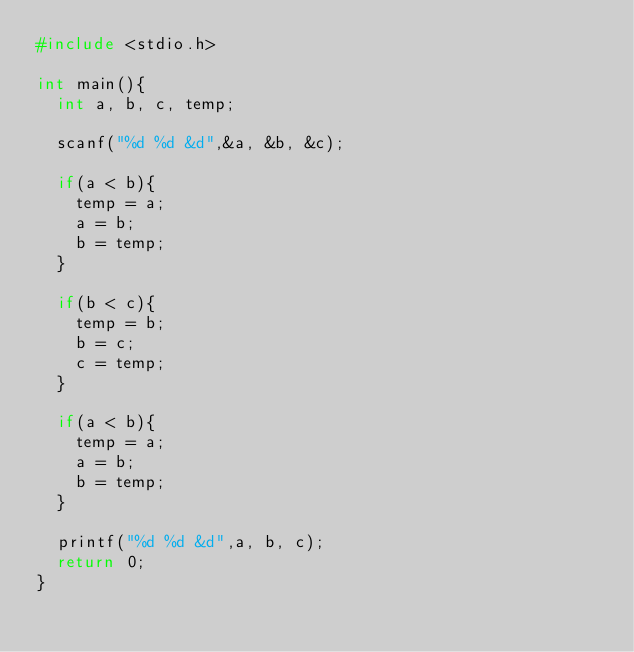<code> <loc_0><loc_0><loc_500><loc_500><_C_>#include <stdio.h>

int main(){
	int a, b, c, temp;
	
	scanf("%d %d &d",&a, &b, &c);
	
	if(a < b){
		temp = a;
		a = b;
		b = temp;	
	}
	
	if(b < c){
		temp = b;
		b = c;
		c = temp;	
	}
	
	if(a < b){
		temp = a;
		a = b;
		b = temp;	
	}
	
	printf("%d %d &d",a, b, c);
	return 0;
}</code> 